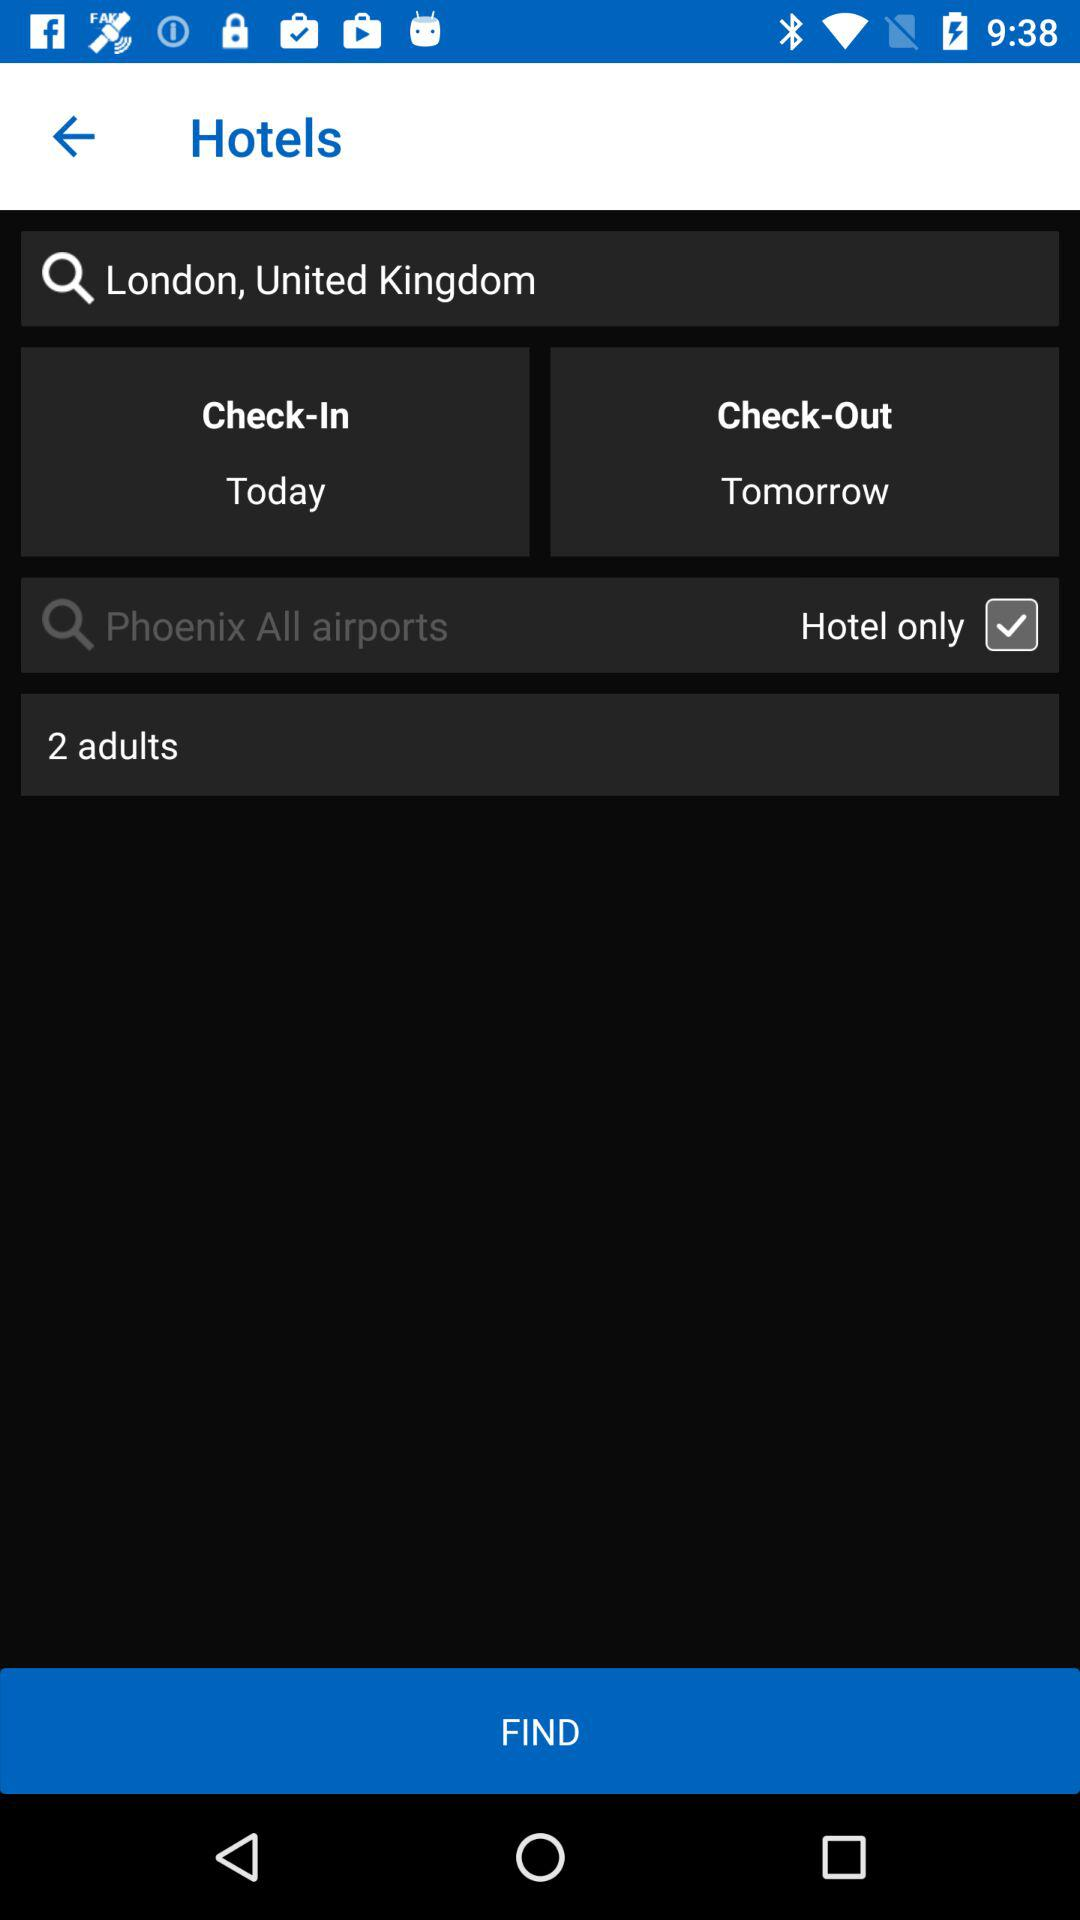What is the check-out date from the hotel? The check-out date is tomorrow. 